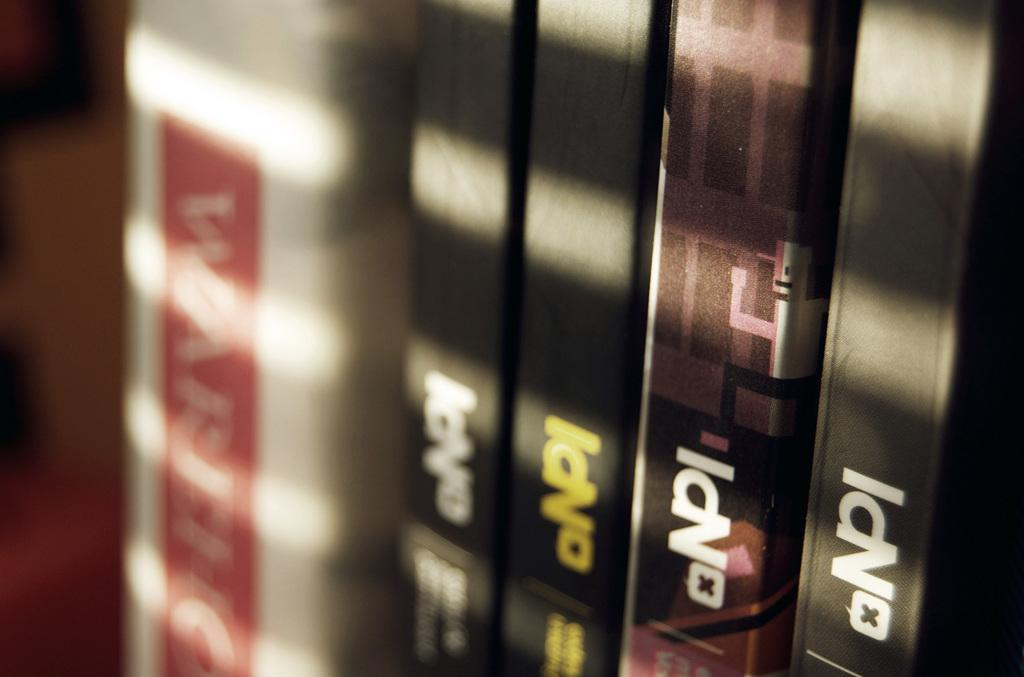<image>
Describe the image concisely. A row of books that all say NPI. 